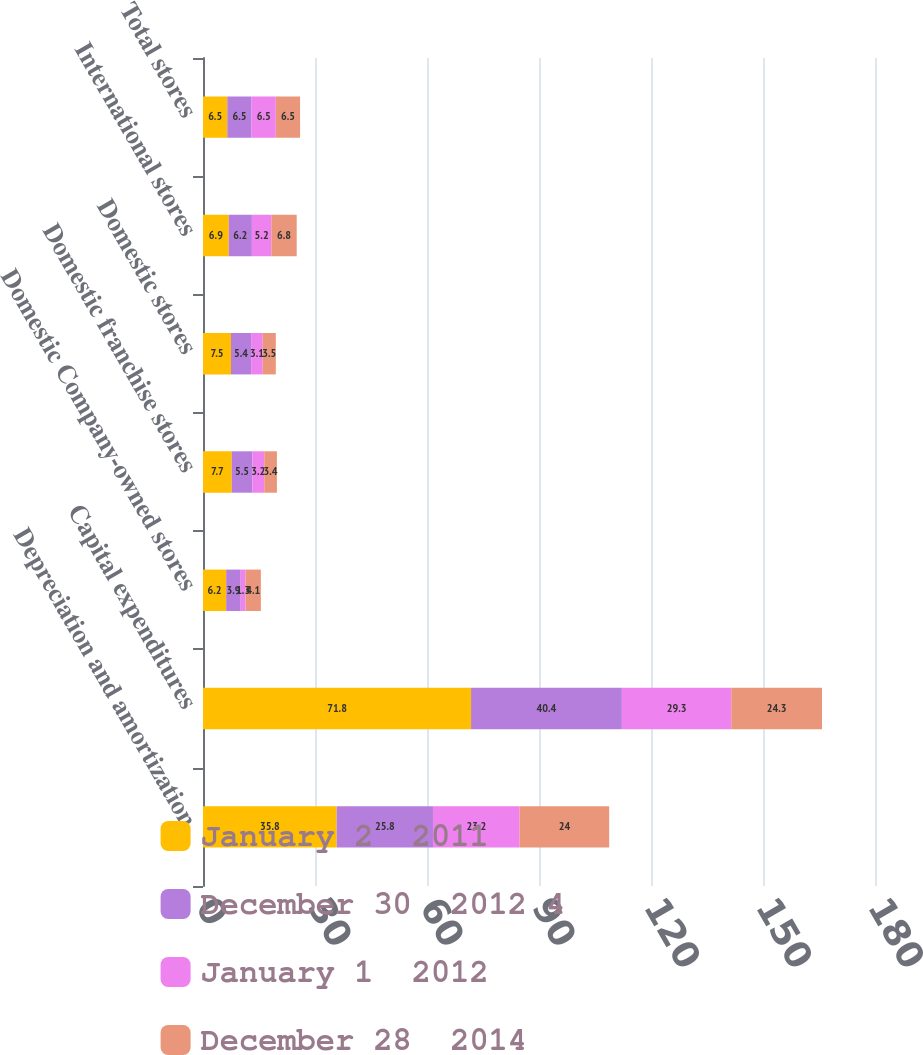Convert chart. <chart><loc_0><loc_0><loc_500><loc_500><stacked_bar_chart><ecel><fcel>Depreciation and amortization<fcel>Capital expenditures<fcel>Domestic Company-owned stores<fcel>Domestic franchise stores<fcel>Domestic stores<fcel>International stores<fcel>Total stores<nl><fcel>January 2  2011<fcel>35.8<fcel>71.8<fcel>6.2<fcel>7.7<fcel>7.5<fcel>6.9<fcel>6.5<nl><fcel>December 30  2012 4<fcel>25.8<fcel>40.4<fcel>3.9<fcel>5.5<fcel>5.4<fcel>6.2<fcel>6.5<nl><fcel>January 1  2012<fcel>23.2<fcel>29.3<fcel>1.3<fcel>3.2<fcel>3.1<fcel>5.2<fcel>6.5<nl><fcel>December 28  2014<fcel>24<fcel>24.3<fcel>4.1<fcel>3.4<fcel>3.5<fcel>6.8<fcel>6.5<nl></chart> 